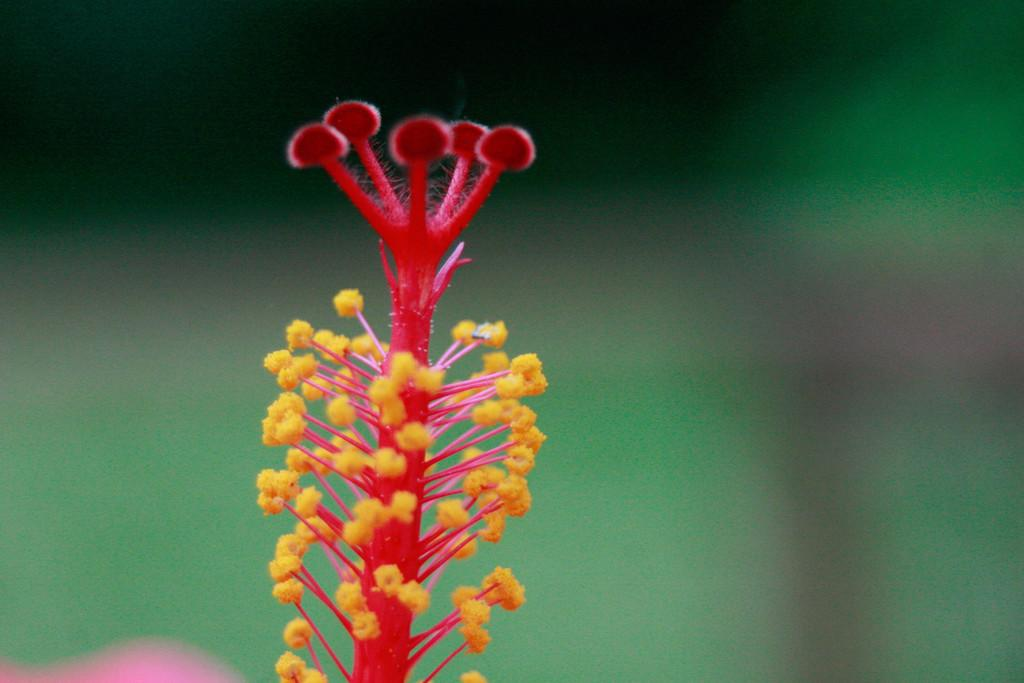What color is the pollen tube in the image? The pollen tube in the image is red. What other elements are present alongside the pollen tube? The pollen tube is accompanied by stamens. Can you describe the background of the image? The background of the image is blurred. How many ducks can be seen on the hill in the image? There are no ducks or hills present in the image. What time does the clock show in the image? There are no clocks present in the image. 